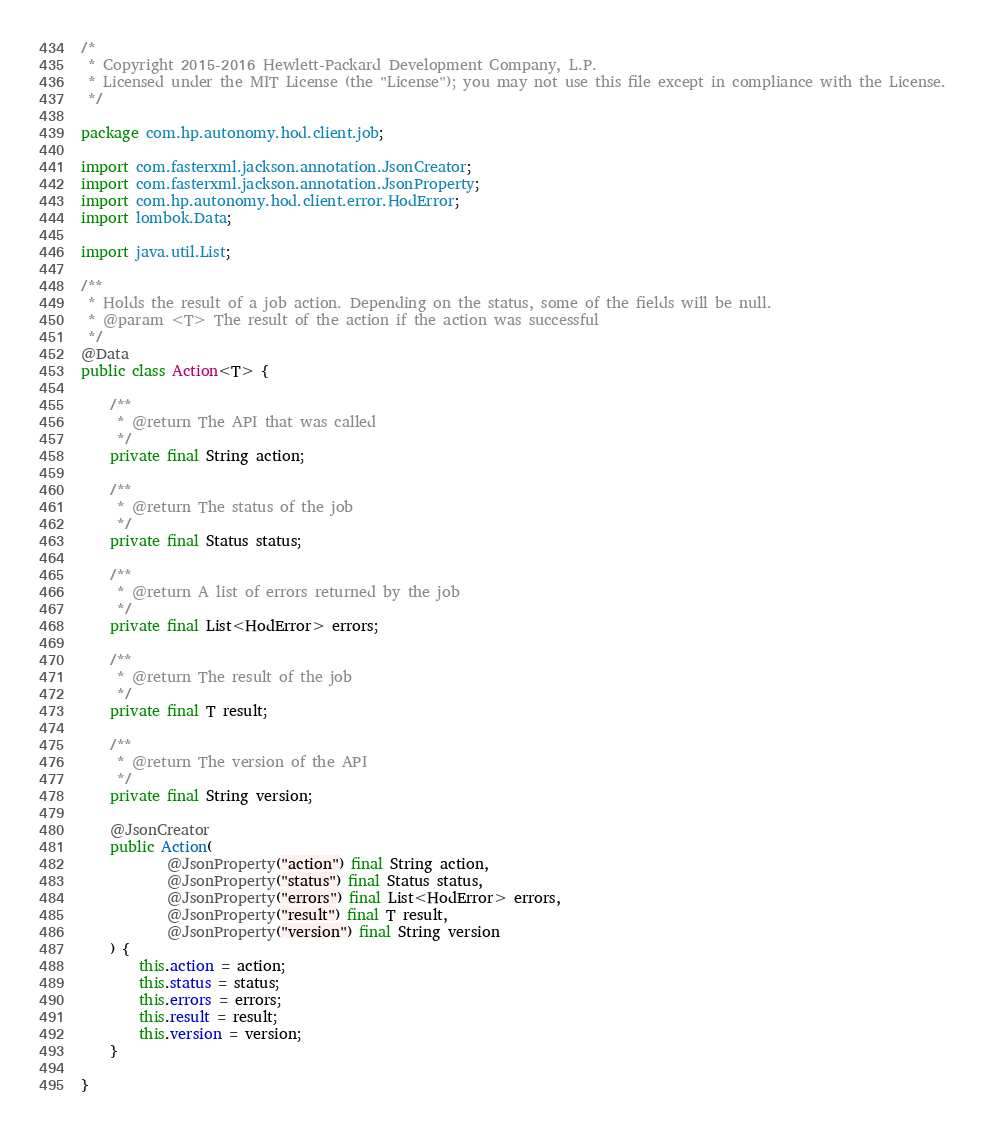<code> <loc_0><loc_0><loc_500><loc_500><_Java_>/*
 * Copyright 2015-2016 Hewlett-Packard Development Company, L.P.
 * Licensed under the MIT License (the "License"); you may not use this file except in compliance with the License.
 */

package com.hp.autonomy.hod.client.job;

import com.fasterxml.jackson.annotation.JsonCreator;
import com.fasterxml.jackson.annotation.JsonProperty;
import com.hp.autonomy.hod.client.error.HodError;
import lombok.Data;

import java.util.List;

/**
 * Holds the result of a job action. Depending on the status, some of the fields will be null.
 * @param <T> The result of the action if the action was successful
 */
@Data
public class Action<T> {

    /**
     * @return The API that was called
     */
    private final String action;

    /**
     * @return The status of the job
     */
    private final Status status;

    /**
     * @return A list of errors returned by the job
     */
    private final List<HodError> errors;

    /**
     * @return The result of the job
     */
    private final T result;

    /**
     * @return The version of the API
     */
    private final String version;

    @JsonCreator
    public Action(
            @JsonProperty("action") final String action,
            @JsonProperty("status") final Status status,
            @JsonProperty("errors") final List<HodError> errors,
            @JsonProperty("result") final T result,
            @JsonProperty("version") final String version
    ) {
        this.action = action;
        this.status = status;
        this.errors = errors;
        this.result = result;
        this.version = version;
    }

}
</code> 